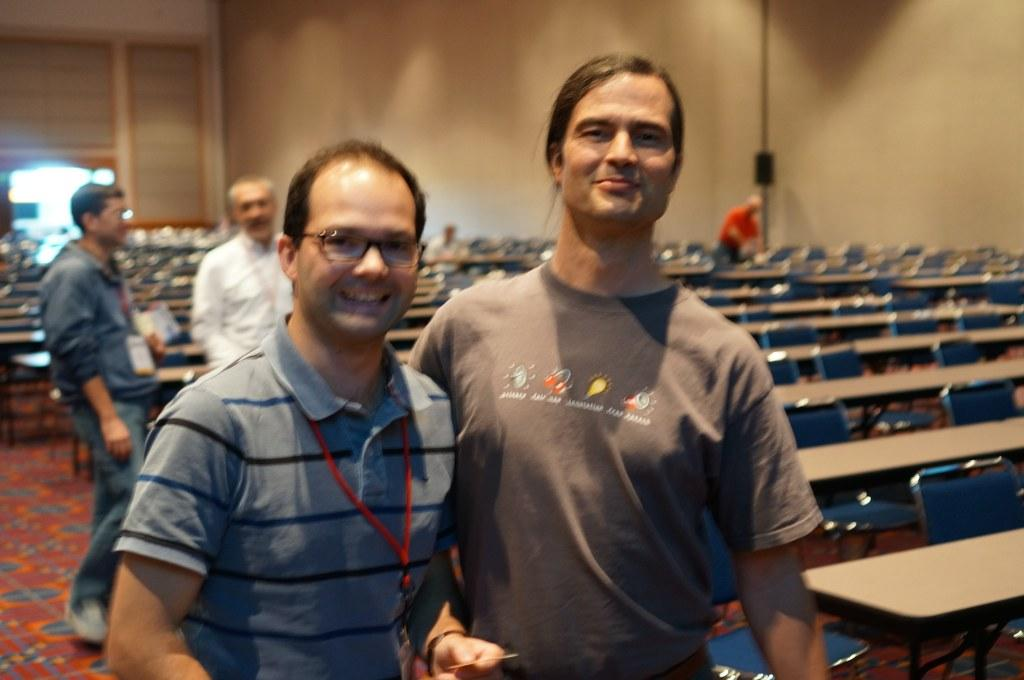What can be seen in the image involving people? There are persons standing in the image. What type of seating is present in the image? There are benches and chairs in the image. What is visible in the background of the image? There is a wall in the background of the image. What type of thread is being used by the persons in the image? There is no thread visible in the image, as the persons are standing and not engaged in any activity involving thread. 